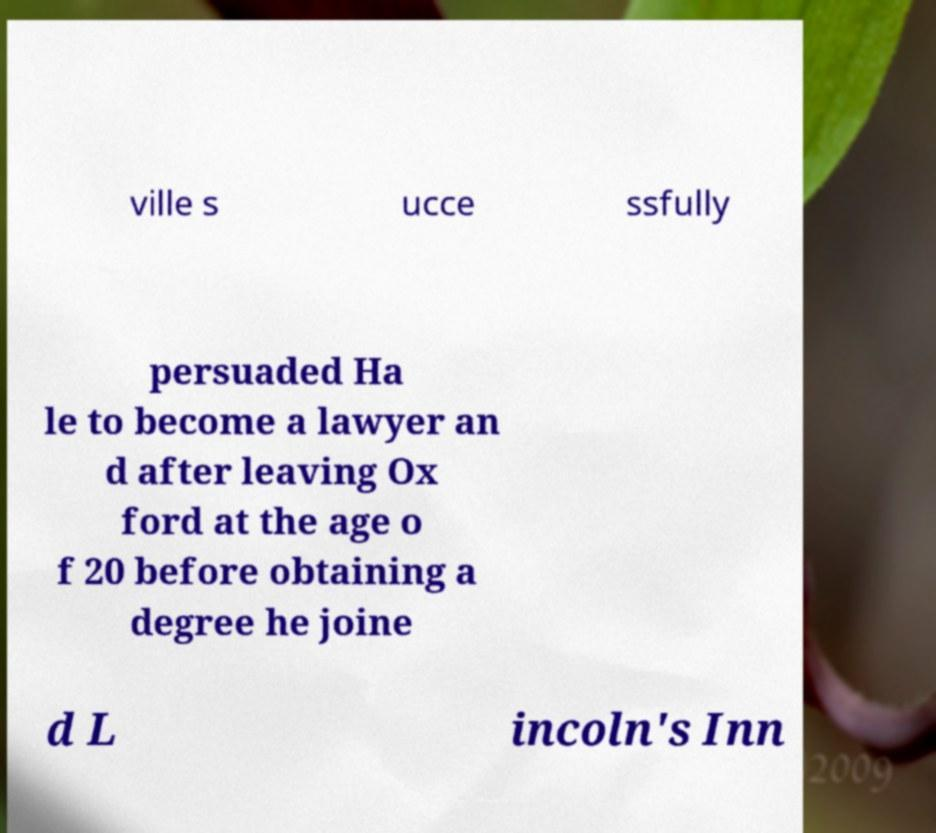Could you extract and type out the text from this image? ville s ucce ssfully persuaded Ha le to become a lawyer an d after leaving Ox ford at the age o f 20 before obtaining a degree he joine d L incoln's Inn 